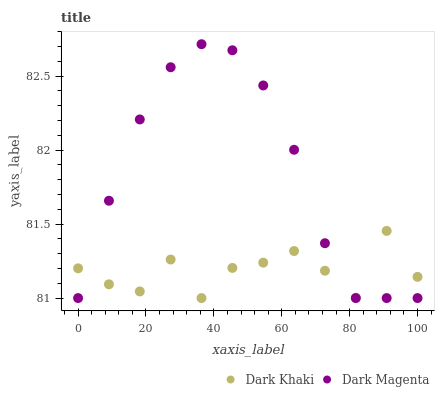Does Dark Khaki have the minimum area under the curve?
Answer yes or no. Yes. Does Dark Magenta have the maximum area under the curve?
Answer yes or no. Yes. Does Dark Magenta have the minimum area under the curve?
Answer yes or no. No. Is Dark Magenta the smoothest?
Answer yes or no. Yes. Is Dark Khaki the roughest?
Answer yes or no. Yes. Is Dark Magenta the roughest?
Answer yes or no. No. Does Dark Khaki have the lowest value?
Answer yes or no. Yes. Does Dark Magenta have the highest value?
Answer yes or no. Yes. Does Dark Khaki intersect Dark Magenta?
Answer yes or no. Yes. Is Dark Khaki less than Dark Magenta?
Answer yes or no. No. Is Dark Khaki greater than Dark Magenta?
Answer yes or no. No. 